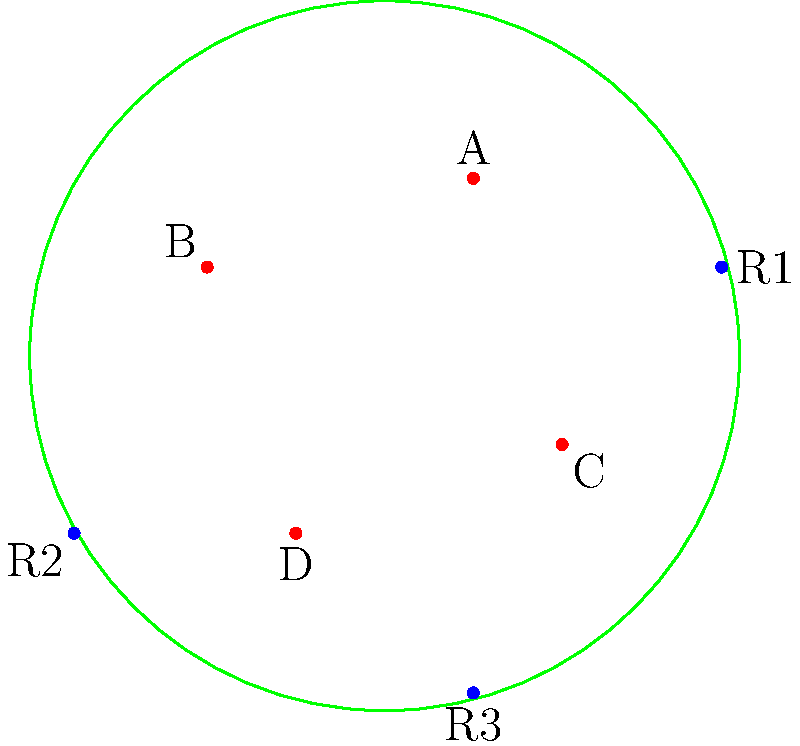The diagram represents a host cell with four SARS-CoV-2 viral particles (A, B, C, and D) and three receptor proteins (R1, R2, and R3) on the cell membrane. Based on the spatial arrangement, which viral particle is most likely to bind to receptor R3 and initiate cell entry? To determine which viral particle is most likely to bind to receptor R3 and initiate cell entry, we need to consider the spatial arrangement and proximity of the viral particles to the receptor. Let's analyze this step-by-step:

1. Identify the location of receptor R3:
   R3 is positioned at the bottom of the cell membrane.

2. Assess the distances between R3 and each viral particle:
   A: Located in the upper right quadrant, far from R3.
   B: Positioned in the upper left quadrant, far from R3.
   C: Situated in the lower right quadrant, relatively close to R3.
   D: Located in the lower left quadrant, closest to R3.

3. Consider the binding mechanism:
   SARS-CoV-2 uses its spike protein to bind to the ACE2 receptor on host cells. The binding process is distance-dependent, with closer proximity increasing the likelihood of interaction.

4. Evaluate the probability of binding:
   Based on the spatial arrangement, particle D is the closest to receptor R3 and has the shortest distance to travel for binding.

5. Account for viral dynamics:
   While viral particles can move within the extracellular space, the particle with the highest probability of binding is the one already in closest proximity to the receptor.

Therefore, viral particle D is most likely to bind to receptor R3 and initiate cell entry due to its closest proximity among all particles.
Answer: D 